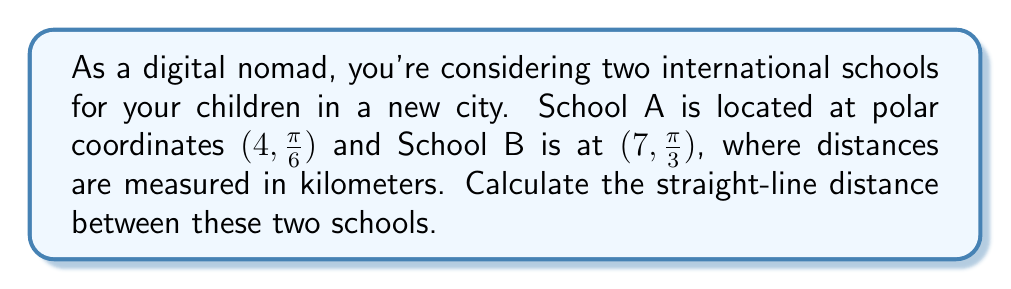Teach me how to tackle this problem. To find the distance between two points in polar coordinates, we can use the polar form of the distance formula:

$$d = \sqrt{r_1^2 + r_2^2 - 2r_1r_2\cos(\theta_2 - \theta_1)}$$

Where:
- $d$ is the distance between the two points
- $(r_1, \theta_1)$ are the coordinates of the first point
- $(r_2, \theta_2)$ are the coordinates of the second point

Let's plug in our values:
- School A: $r_1 = 4$, $\theta_1 = \frac{\pi}{6}$
- School B: $r_2 = 7$, $\theta_2 = \frac{\pi}{3}$

Now, let's calculate step by step:

1) First, calculate $\theta_2 - \theta_1$:
   $$\frac{\pi}{3} - \frac{\pi}{6} = \frac{\pi}{6}$$

2) Now, let's substitute all values into the formula:
   $$d = \sqrt{4^2 + 7^2 - 2(4)(7)\cos(\frac{\pi}{6})}$$

3) Simplify inside the square root:
   $$d = \sqrt{16 + 49 - 56\cos(\frac{\pi}{6})}$$

4) Calculate $\cos(\frac{\pi}{6})$:
   $$\cos(\frac{\pi}{6}) = \frac{\sqrt{3}}{2}$$

5) Substitute this value:
   $$d = \sqrt{16 + 49 - 56(\frac{\sqrt{3}}{2})}$$

6) Simplify:
   $$d = \sqrt{65 - 28\sqrt{3}}$$

This is our final answer in exact form. If we want a decimal approximation:

7) Calculate the value under the square root:
   $$65 - 28\sqrt{3} \approx 16.5147$$

8) Take the square root:
   $$d \approx \sqrt{16.5147} \approx 4.0638$$

Therefore, the distance between the two schools is approximately 4.0638 kilometers.
Answer: The exact distance is $\sqrt{65 - 28\sqrt{3}}$ km, or approximately 4.0638 km. 